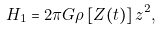<formula> <loc_0><loc_0><loc_500><loc_500>H _ { 1 } = 2 \pi G \rho \left [ Z ( t ) \right ] z ^ { 2 } ,</formula> 